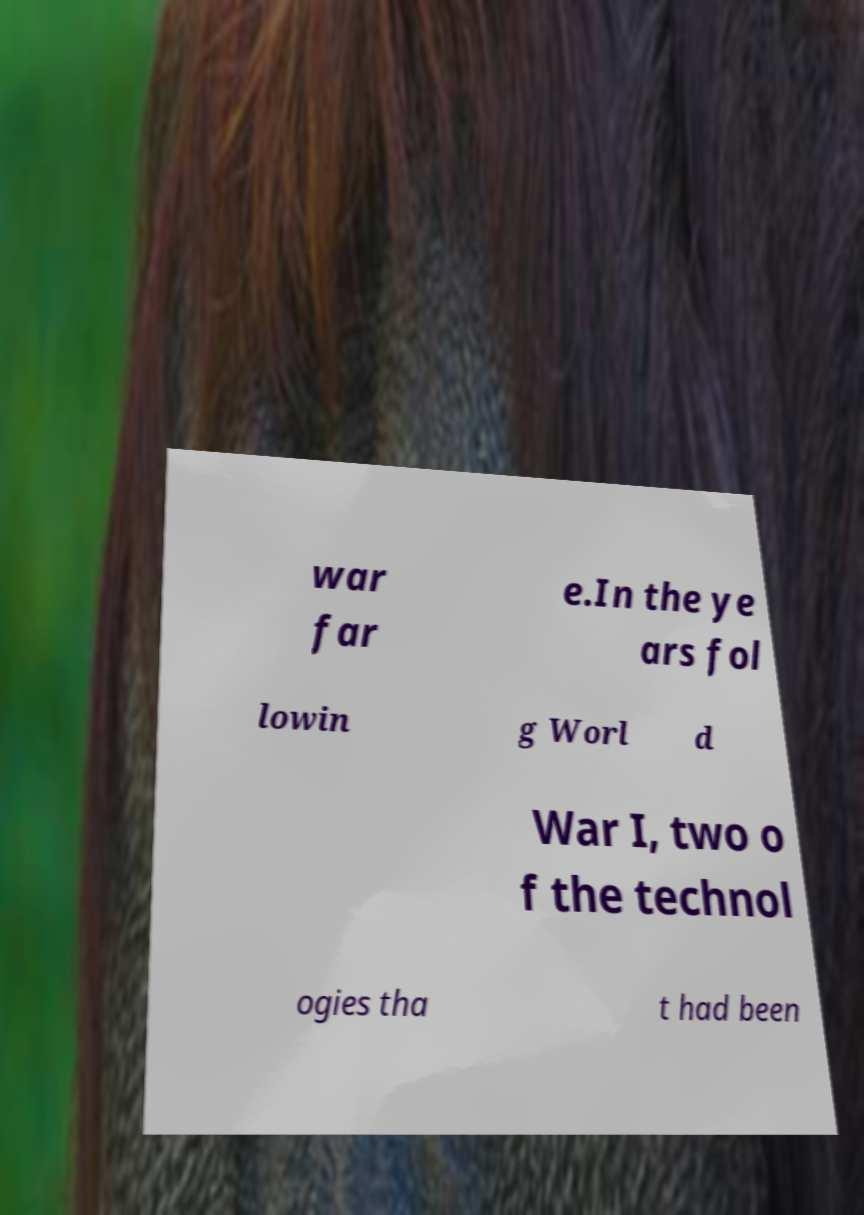Could you extract and type out the text from this image? war far e.In the ye ars fol lowin g Worl d War I, two o f the technol ogies tha t had been 